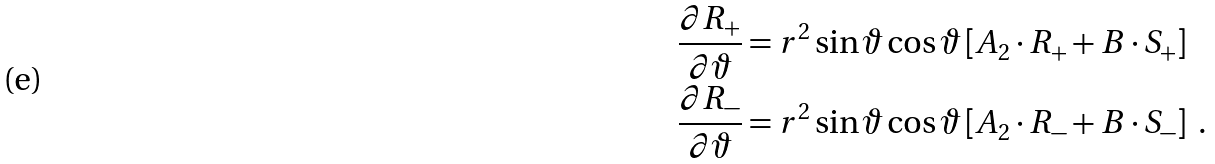Convert formula to latex. <formula><loc_0><loc_0><loc_500><loc_500>\frac { \partial R _ { + } } { \partial \vartheta } & = r ^ { 2 } \sin \vartheta \cos \vartheta \left [ A _ { 2 } \cdot R _ { + } + B \cdot S _ { + } \right ] \\ \frac { \partial R _ { - } } { \partial \vartheta } & = r ^ { 2 } \sin \vartheta \cos \vartheta \left [ A _ { 2 } \cdot R _ { - } + B \cdot S _ { - } \right ] \ .</formula> 